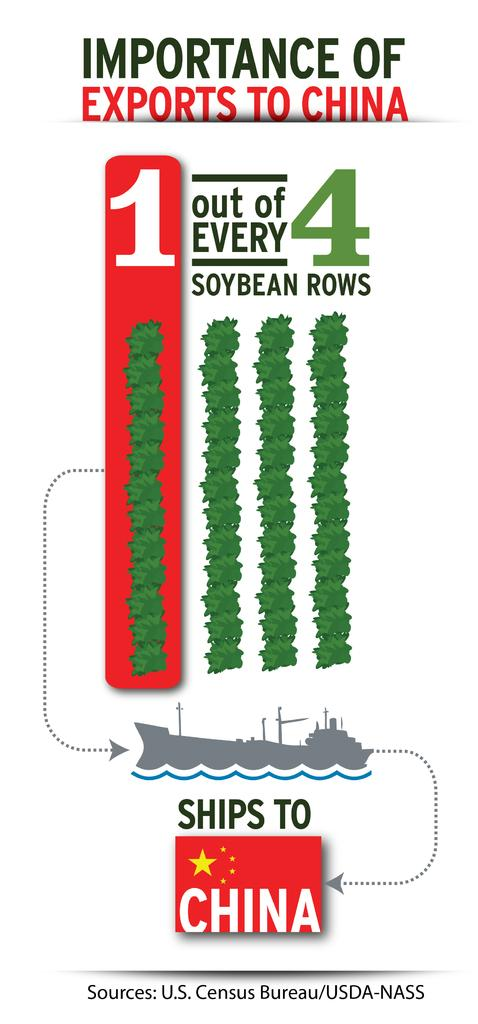<image>
Give a short and clear explanation of the subsequent image. Poster that tells people the Importance of Exports to China. 